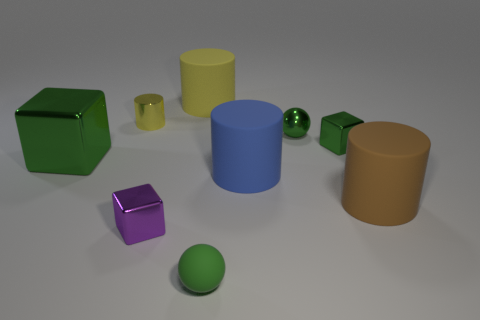Imagine these objects are part of a child's toy set. How would you describe the set to someone? This image appears to depict a colorful, educational toy set designed for children, which would be excellent for teaching shapes and colors. It includes a variety of geometric objects, such as cubes, cylinders, and spheres, each rendered in eye-catching, solid colors like green, purple, yellow, and blue. These items, due to their simple and bold design, would be great for hands-on learning about geometry, spatial relations, and color identification. 